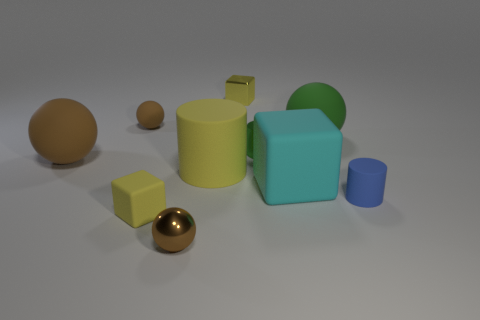Subtract all matte cylinders. How many cylinders are left? 1 Subtract all cyan cubes. How many cubes are left? 2 Subtract 1 cylinders. How many cylinders are left? 2 Subtract all cubes. How many objects are left? 7 Add 5 green shiny objects. How many green shiny objects are left? 6 Add 4 tiny blue things. How many tiny blue things exist? 5 Subtract 1 blue cylinders. How many objects are left? 9 Subtract all red balls. Subtract all green cylinders. How many balls are left? 4 Subtract all blue spheres. How many yellow cylinders are left? 1 Subtract all brown shiny spheres. Subtract all large green things. How many objects are left? 8 